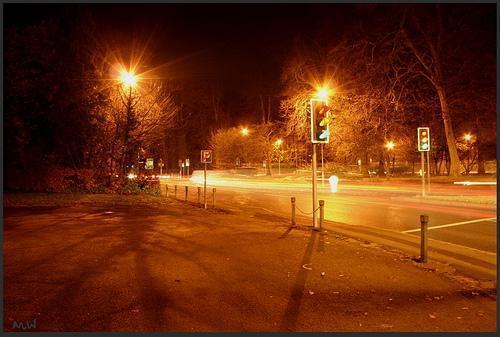How many lights are red?
Give a very brief answer. 0. How many cabs are in the picture?
Give a very brief answer. 0. 